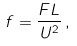Convert formula to latex. <formula><loc_0><loc_0><loc_500><loc_500>f = \frac { F L } { U ^ { 2 } } \, ,</formula> 